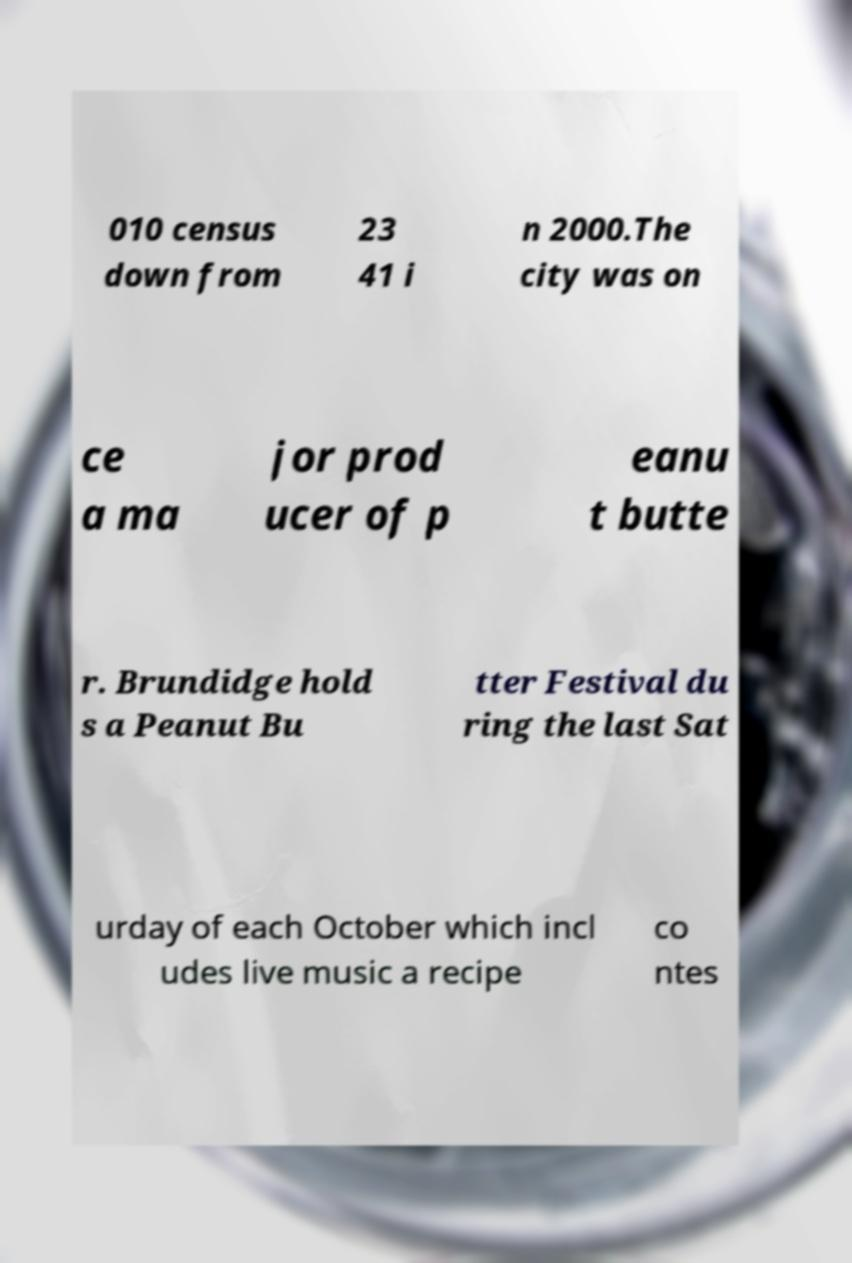Could you assist in decoding the text presented in this image and type it out clearly? 010 census down from 23 41 i n 2000.The city was on ce a ma jor prod ucer of p eanu t butte r. Brundidge hold s a Peanut Bu tter Festival du ring the last Sat urday of each October which incl udes live music a recipe co ntes 